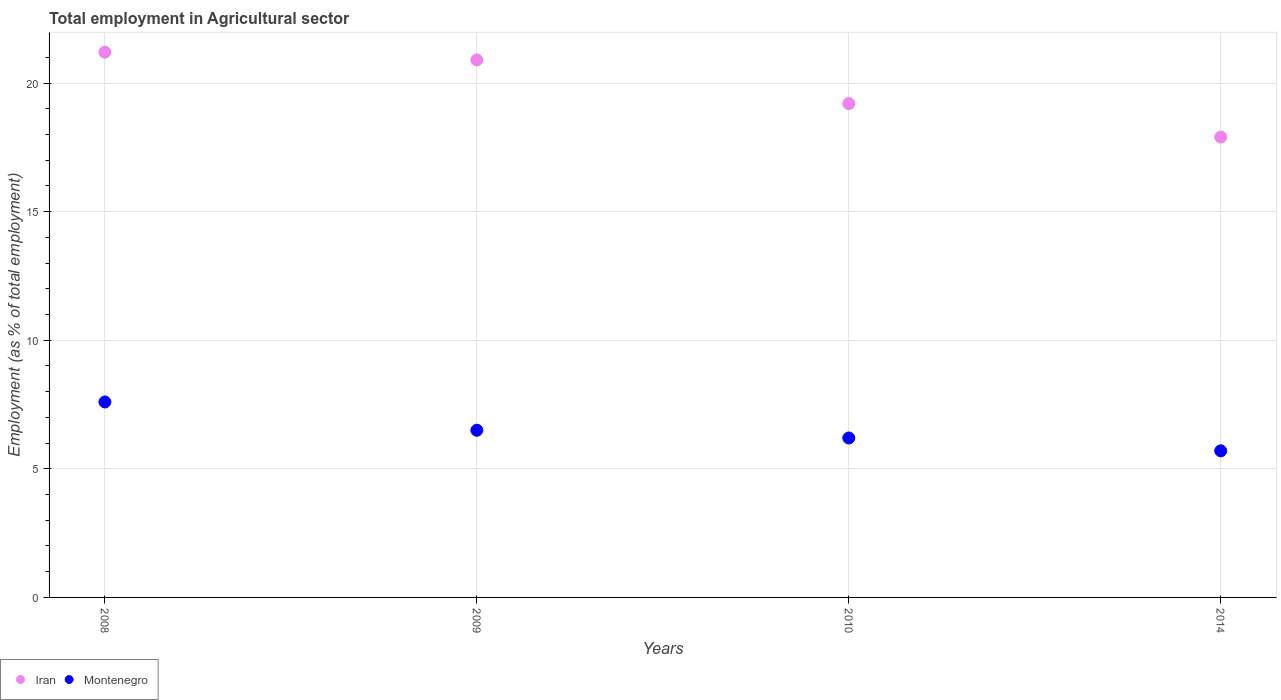How many different coloured dotlines are there?
Make the answer very short. 2. What is the employment in agricultural sector in Iran in 2014?
Provide a succinct answer. 17.9. Across all years, what is the maximum employment in agricultural sector in Montenegro?
Keep it short and to the point. 7.6. Across all years, what is the minimum employment in agricultural sector in Iran?
Offer a very short reply. 17.9. In which year was the employment in agricultural sector in Montenegro maximum?
Ensure brevity in your answer.  2008. What is the total employment in agricultural sector in Montenegro in the graph?
Provide a succinct answer. 26. What is the difference between the employment in agricultural sector in Montenegro in 2009 and that in 2010?
Give a very brief answer. 0.3. What is the difference between the employment in agricultural sector in Montenegro in 2014 and the employment in agricultural sector in Iran in 2010?
Your answer should be compact. -13.5. What is the average employment in agricultural sector in Iran per year?
Offer a terse response. 19.8. In the year 2008, what is the difference between the employment in agricultural sector in Iran and employment in agricultural sector in Montenegro?
Offer a very short reply. 13.6. In how many years, is the employment in agricultural sector in Iran greater than 15 %?
Keep it short and to the point. 4. What is the ratio of the employment in agricultural sector in Montenegro in 2009 to that in 2010?
Your answer should be compact. 1.05. Is the difference between the employment in agricultural sector in Iran in 2008 and 2014 greater than the difference between the employment in agricultural sector in Montenegro in 2008 and 2014?
Offer a terse response. Yes. What is the difference between the highest and the second highest employment in agricultural sector in Iran?
Make the answer very short. 0.3. What is the difference between the highest and the lowest employment in agricultural sector in Montenegro?
Your answer should be compact. 1.9. In how many years, is the employment in agricultural sector in Iran greater than the average employment in agricultural sector in Iran taken over all years?
Your answer should be compact. 2. Does the employment in agricultural sector in Montenegro monotonically increase over the years?
Keep it short and to the point. No. Is the employment in agricultural sector in Iran strictly greater than the employment in agricultural sector in Montenegro over the years?
Your answer should be very brief. Yes. How many years are there in the graph?
Keep it short and to the point. 4. Where does the legend appear in the graph?
Provide a short and direct response. Bottom left. How many legend labels are there?
Offer a terse response. 2. What is the title of the graph?
Make the answer very short. Total employment in Agricultural sector. Does "Tuvalu" appear as one of the legend labels in the graph?
Your answer should be compact. No. What is the label or title of the Y-axis?
Offer a terse response. Employment (as % of total employment). What is the Employment (as % of total employment) in Iran in 2008?
Offer a terse response. 21.2. What is the Employment (as % of total employment) in Montenegro in 2008?
Give a very brief answer. 7.6. What is the Employment (as % of total employment) in Iran in 2009?
Your answer should be compact. 20.9. What is the Employment (as % of total employment) in Montenegro in 2009?
Ensure brevity in your answer.  6.5. What is the Employment (as % of total employment) in Iran in 2010?
Offer a terse response. 19.2. What is the Employment (as % of total employment) in Montenegro in 2010?
Offer a terse response. 6.2. What is the Employment (as % of total employment) of Iran in 2014?
Your answer should be compact. 17.9. What is the Employment (as % of total employment) in Montenegro in 2014?
Your answer should be compact. 5.7. Across all years, what is the maximum Employment (as % of total employment) in Iran?
Offer a terse response. 21.2. Across all years, what is the maximum Employment (as % of total employment) in Montenegro?
Provide a short and direct response. 7.6. Across all years, what is the minimum Employment (as % of total employment) in Iran?
Offer a terse response. 17.9. Across all years, what is the minimum Employment (as % of total employment) in Montenegro?
Your answer should be compact. 5.7. What is the total Employment (as % of total employment) in Iran in the graph?
Your answer should be compact. 79.2. What is the total Employment (as % of total employment) in Montenegro in the graph?
Your response must be concise. 26. What is the difference between the Employment (as % of total employment) in Iran in 2008 and that in 2010?
Offer a terse response. 2. What is the difference between the Employment (as % of total employment) in Montenegro in 2008 and that in 2010?
Offer a very short reply. 1.4. What is the difference between the Employment (as % of total employment) in Montenegro in 2008 and that in 2014?
Give a very brief answer. 1.9. What is the difference between the Employment (as % of total employment) in Montenegro in 2009 and that in 2014?
Give a very brief answer. 0.8. What is the difference between the Employment (as % of total employment) of Iran in 2010 and that in 2014?
Provide a succinct answer. 1.3. What is the difference between the Employment (as % of total employment) of Montenegro in 2010 and that in 2014?
Offer a terse response. 0.5. What is the difference between the Employment (as % of total employment) of Iran in 2008 and the Employment (as % of total employment) of Montenegro in 2009?
Ensure brevity in your answer.  14.7. What is the difference between the Employment (as % of total employment) in Iran in 2008 and the Employment (as % of total employment) in Montenegro in 2010?
Make the answer very short. 15. What is the difference between the Employment (as % of total employment) of Iran in 2009 and the Employment (as % of total employment) of Montenegro in 2014?
Your response must be concise. 15.2. What is the average Employment (as % of total employment) of Iran per year?
Your answer should be compact. 19.8. What is the average Employment (as % of total employment) of Montenegro per year?
Provide a short and direct response. 6.5. In the year 2008, what is the difference between the Employment (as % of total employment) in Iran and Employment (as % of total employment) in Montenegro?
Provide a short and direct response. 13.6. In the year 2009, what is the difference between the Employment (as % of total employment) of Iran and Employment (as % of total employment) of Montenegro?
Keep it short and to the point. 14.4. In the year 2014, what is the difference between the Employment (as % of total employment) of Iran and Employment (as % of total employment) of Montenegro?
Provide a succinct answer. 12.2. What is the ratio of the Employment (as % of total employment) in Iran in 2008 to that in 2009?
Offer a terse response. 1.01. What is the ratio of the Employment (as % of total employment) of Montenegro in 2008 to that in 2009?
Your response must be concise. 1.17. What is the ratio of the Employment (as % of total employment) of Iran in 2008 to that in 2010?
Your answer should be very brief. 1.1. What is the ratio of the Employment (as % of total employment) in Montenegro in 2008 to that in 2010?
Offer a very short reply. 1.23. What is the ratio of the Employment (as % of total employment) in Iran in 2008 to that in 2014?
Your response must be concise. 1.18. What is the ratio of the Employment (as % of total employment) of Montenegro in 2008 to that in 2014?
Provide a succinct answer. 1.33. What is the ratio of the Employment (as % of total employment) of Iran in 2009 to that in 2010?
Keep it short and to the point. 1.09. What is the ratio of the Employment (as % of total employment) of Montenegro in 2009 to that in 2010?
Your response must be concise. 1.05. What is the ratio of the Employment (as % of total employment) in Iran in 2009 to that in 2014?
Make the answer very short. 1.17. What is the ratio of the Employment (as % of total employment) of Montenegro in 2009 to that in 2014?
Your answer should be very brief. 1.14. What is the ratio of the Employment (as % of total employment) of Iran in 2010 to that in 2014?
Ensure brevity in your answer.  1.07. What is the ratio of the Employment (as % of total employment) of Montenegro in 2010 to that in 2014?
Ensure brevity in your answer.  1.09. What is the difference between the highest and the second highest Employment (as % of total employment) of Montenegro?
Provide a short and direct response. 1.1. What is the difference between the highest and the lowest Employment (as % of total employment) of Iran?
Give a very brief answer. 3.3. 